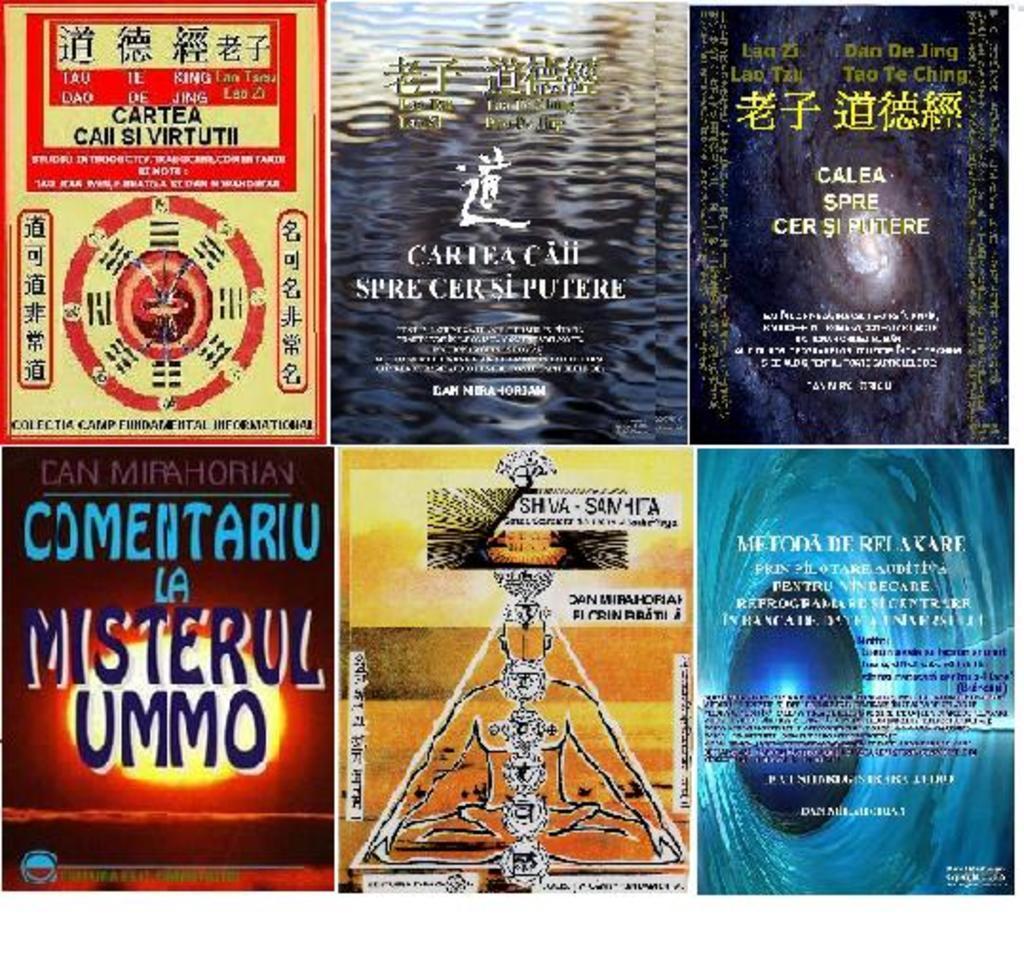Please provide a concise description of this image. In this image I can see six front covers of books. This image is an collaged one. 